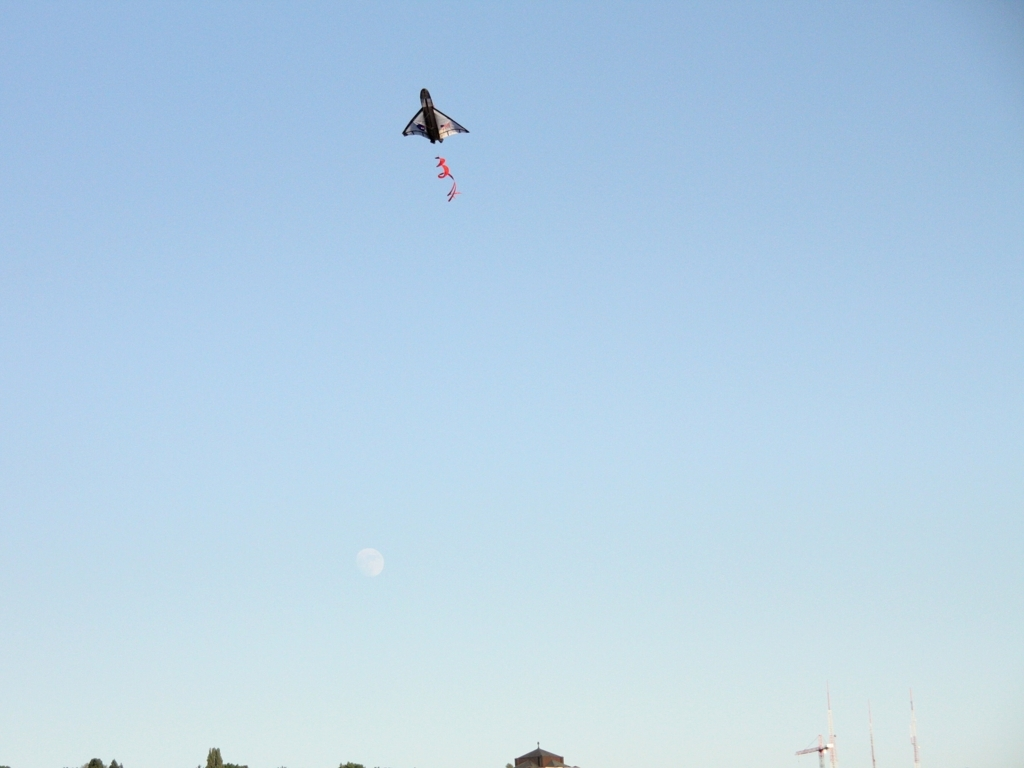What type of flying object is captured in the image? The image shows a delta-wing kite in flight. It is easily recognized by its triangular shape and is often enjoyed for its maneuverability and speed. Can you tell me about the conditions suitable for flying a kite like this? Certainly! Kite flying is optimal with moderate, consistent winds ranging from 8 to 24 miles per hour. Clear, open skies and a spacious field or beach without obstructions like trees and power lines are ideal for flying this type of kite. 